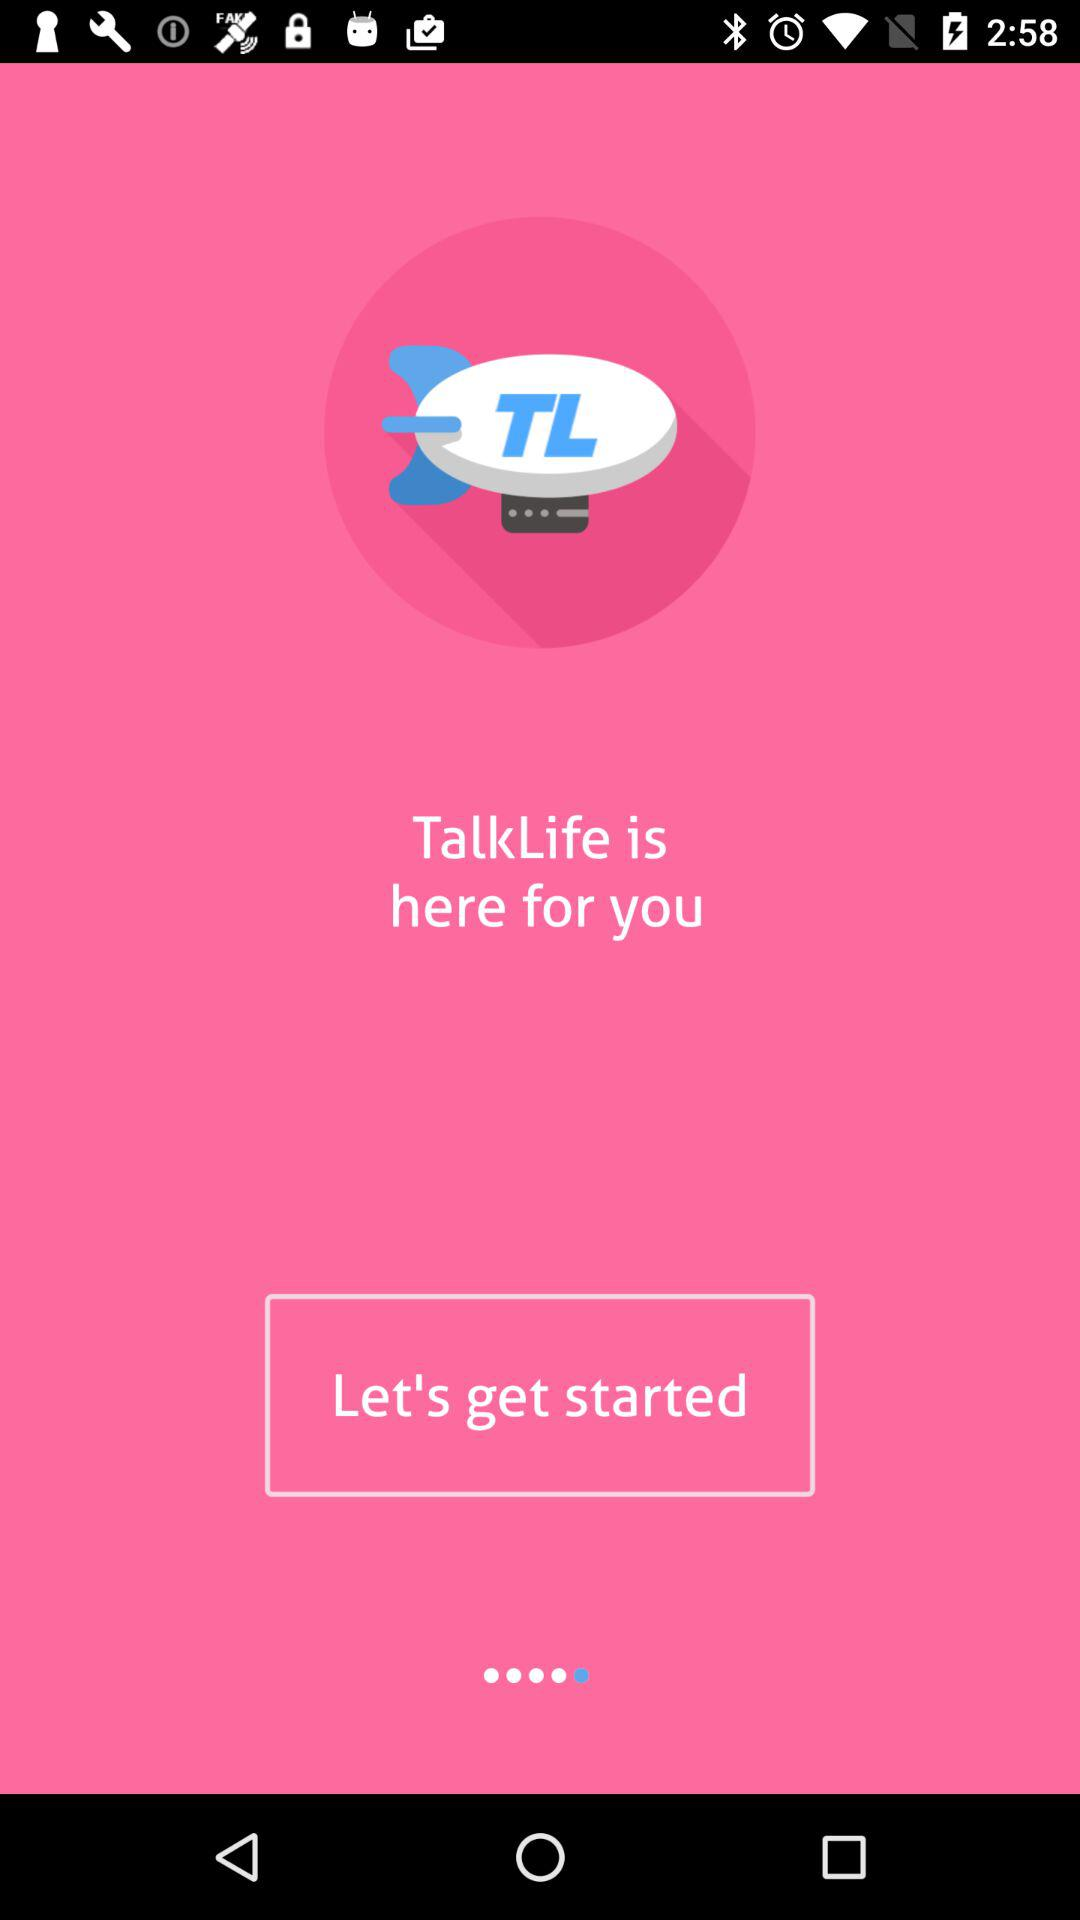What does "TalkLife" do?
When the provided information is insufficient, respond with <no answer>. <no answer> 